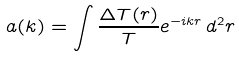Convert formula to latex. <formula><loc_0><loc_0><loc_500><loc_500>a ( { k } ) = \int \frac { \Delta T ( r ) } { T } e ^ { - i { k r } } \, d ^ { 2 } { r }</formula> 